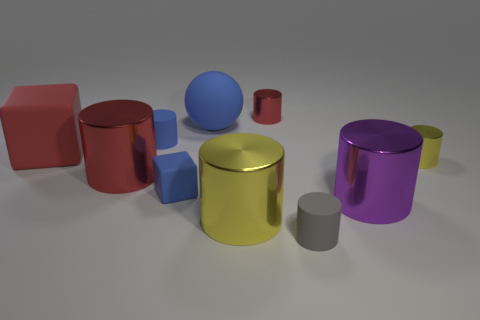Are there any other things that are the same shape as the purple thing?
Provide a succinct answer. Yes. There is a large thing in front of the purple thing; what material is it?
Give a very brief answer. Metal. Is the material of the yellow cylinder on the right side of the gray rubber cylinder the same as the blue sphere?
Ensure brevity in your answer.  No. What number of objects are large cylinders or shiny things that are to the left of the small gray matte cylinder?
Provide a succinct answer. 4. What size is the other matte object that is the same shape as the small gray thing?
Your response must be concise. Small. Are there any other things that have the same size as the red cube?
Ensure brevity in your answer.  Yes. There is a large red shiny object; are there any gray matte things behind it?
Your answer should be compact. No. There is a matte cylinder that is in front of the small yellow metallic object; does it have the same color as the tiny shiny thing that is on the right side of the gray matte cylinder?
Keep it short and to the point. No. Is there a small purple object of the same shape as the tiny gray object?
Offer a terse response. No. How many other things are the same color as the ball?
Your answer should be very brief. 2. 